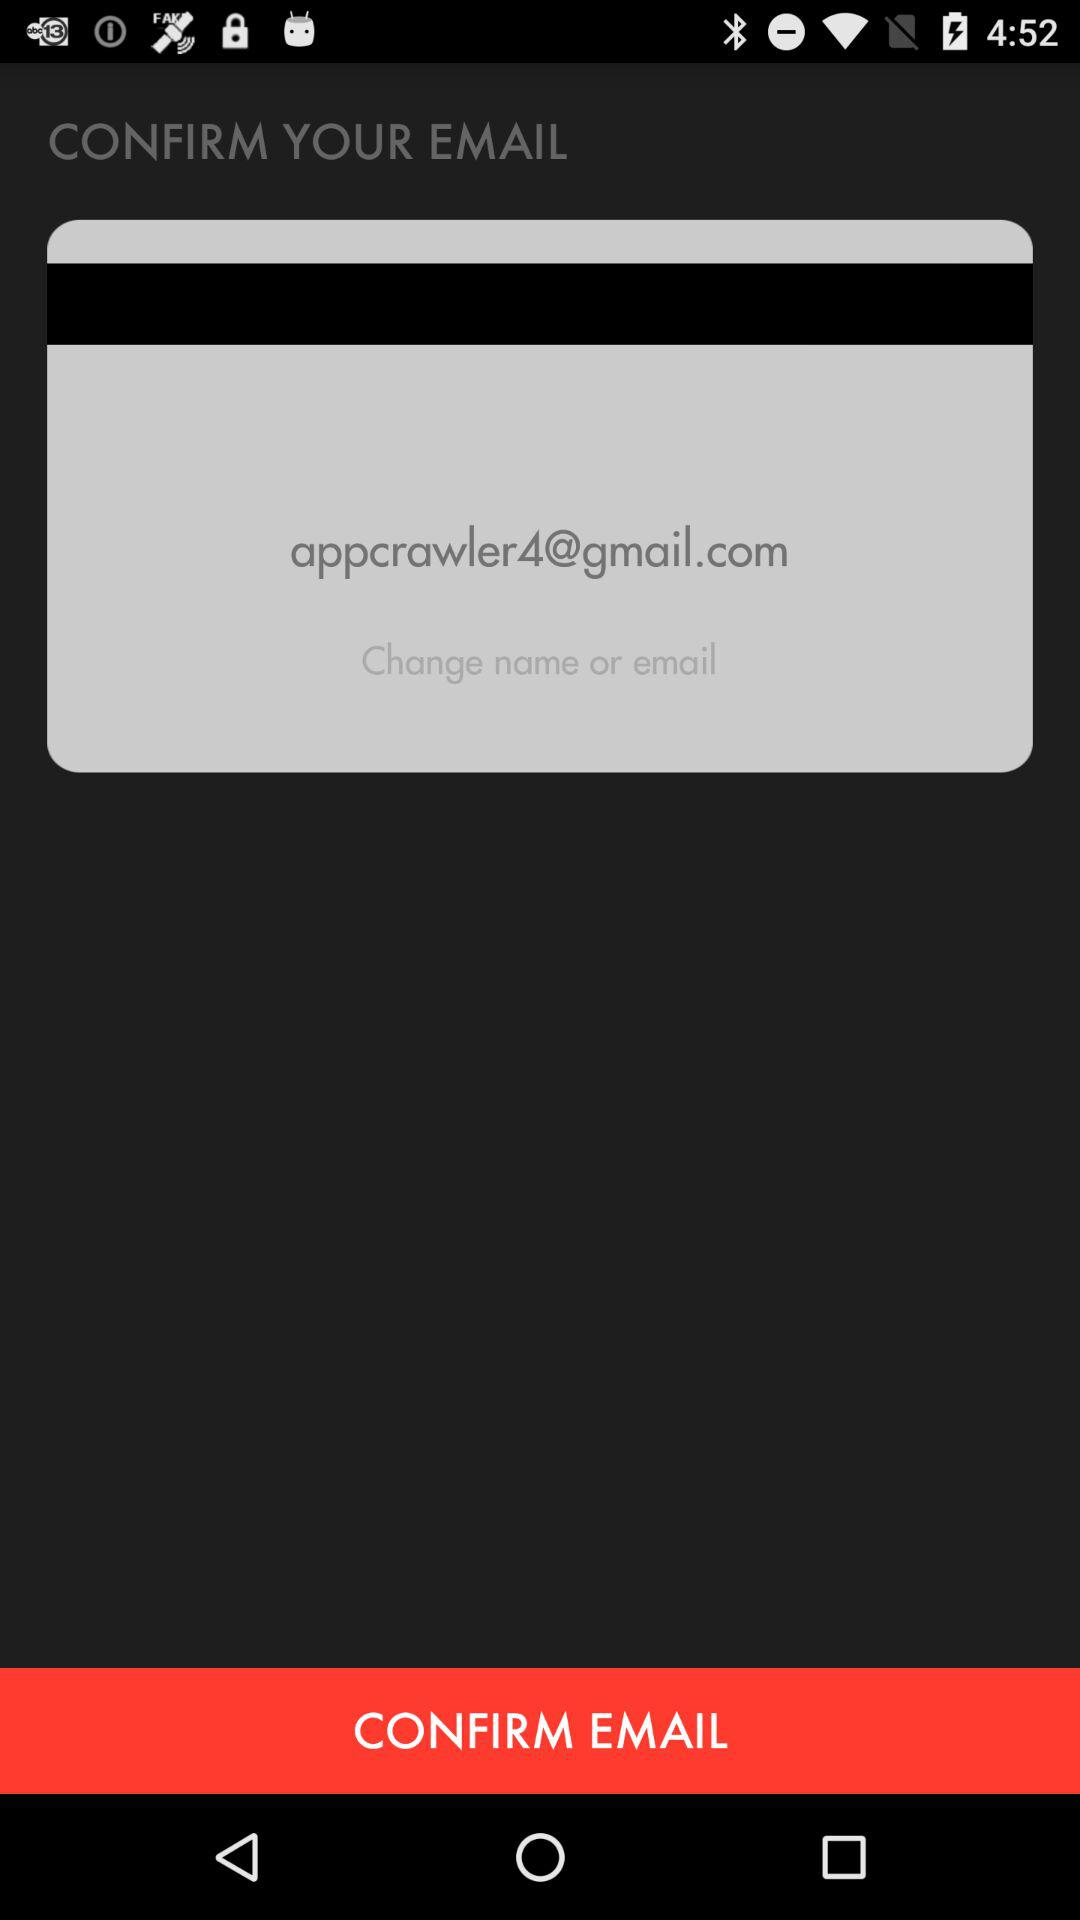What is the email address? The email address is "appcrawler4@gmail.com". 